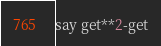<code> <loc_0><loc_0><loc_500><loc_500><_Perl_>say get**2-get</code> 